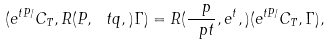Convert formula to latex. <formula><loc_0><loc_0><loc_500><loc_500>( { e ^ { { t P } / { } } } { C _ { T } } , R ( P , { \ t q } , { } ) { \Gamma } ) = R ( { } \frac { \ p } { { \ p } { t } } , { e ^ { t } } , { } ) ( { e ^ { { t P } / { } } } { C _ { T } } , { \Gamma } ) ,</formula> 